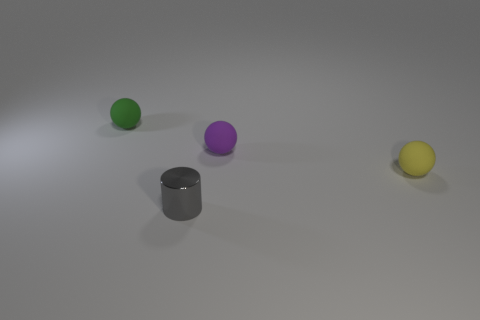What shape is the yellow rubber object?
Make the answer very short. Sphere. What number of things are big blue things or small yellow matte objects?
Give a very brief answer. 1. Do the small matte thing that is on the left side of the tiny gray metal object and the tiny matte ball on the right side of the small purple matte sphere have the same color?
Keep it short and to the point. No. How many other things are the same shape as the yellow thing?
Your answer should be very brief. 2. Are there any small yellow objects?
Your answer should be compact. Yes. What number of objects are either purple rubber balls or tiny objects that are in front of the small green object?
Provide a short and direct response. 3. There is a thing in front of the yellow object; is it the same size as the tiny purple object?
Offer a terse response. Yes. How many other things are the same size as the gray shiny cylinder?
Ensure brevity in your answer.  3. The metallic object is what color?
Offer a very short reply. Gray. What material is the object on the left side of the small gray cylinder?
Provide a short and direct response. Rubber. 